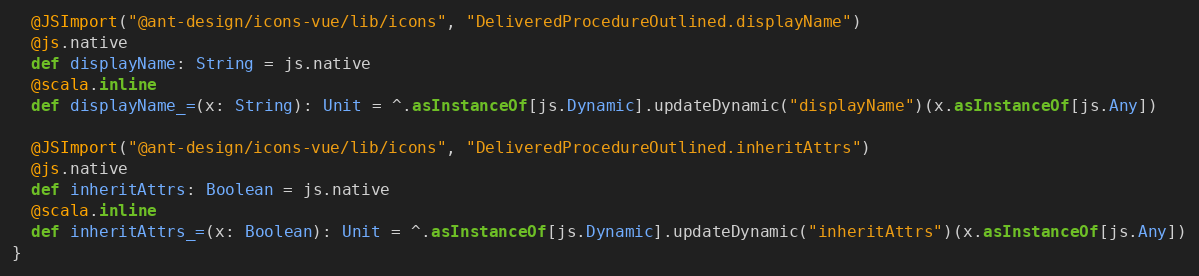<code> <loc_0><loc_0><loc_500><loc_500><_Scala_>  @JSImport("@ant-design/icons-vue/lib/icons", "DeliveredProcedureOutlined.displayName")
  @js.native
  def displayName: String = js.native
  @scala.inline
  def displayName_=(x: String): Unit = ^.asInstanceOf[js.Dynamic].updateDynamic("displayName")(x.asInstanceOf[js.Any])
  
  @JSImport("@ant-design/icons-vue/lib/icons", "DeliveredProcedureOutlined.inheritAttrs")
  @js.native
  def inheritAttrs: Boolean = js.native
  @scala.inline
  def inheritAttrs_=(x: Boolean): Unit = ^.asInstanceOf[js.Dynamic].updateDynamic("inheritAttrs")(x.asInstanceOf[js.Any])
}
</code> 